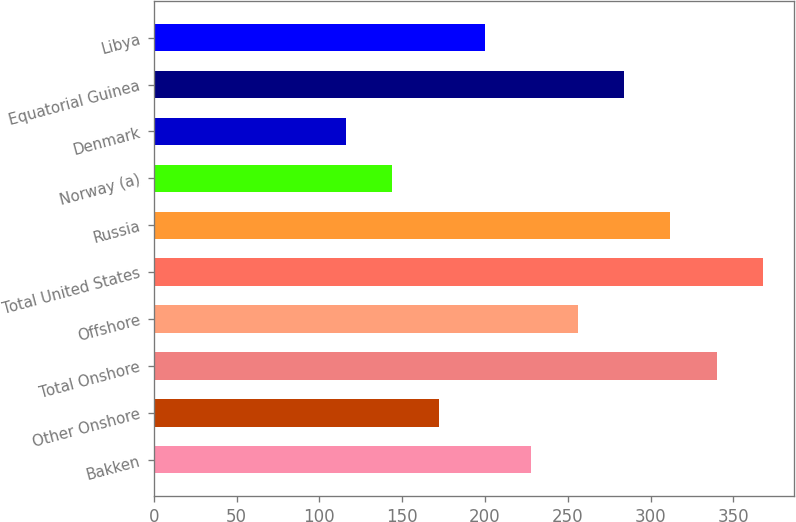Convert chart. <chart><loc_0><loc_0><loc_500><loc_500><bar_chart><fcel>Bakken<fcel>Other Onshore<fcel>Total Onshore<fcel>Offshore<fcel>Total United States<fcel>Russia<fcel>Norway (a)<fcel>Denmark<fcel>Equatorial Guinea<fcel>Libya<nl><fcel>228<fcel>172<fcel>340<fcel>256<fcel>368<fcel>312<fcel>144<fcel>116<fcel>284<fcel>200<nl></chart> 